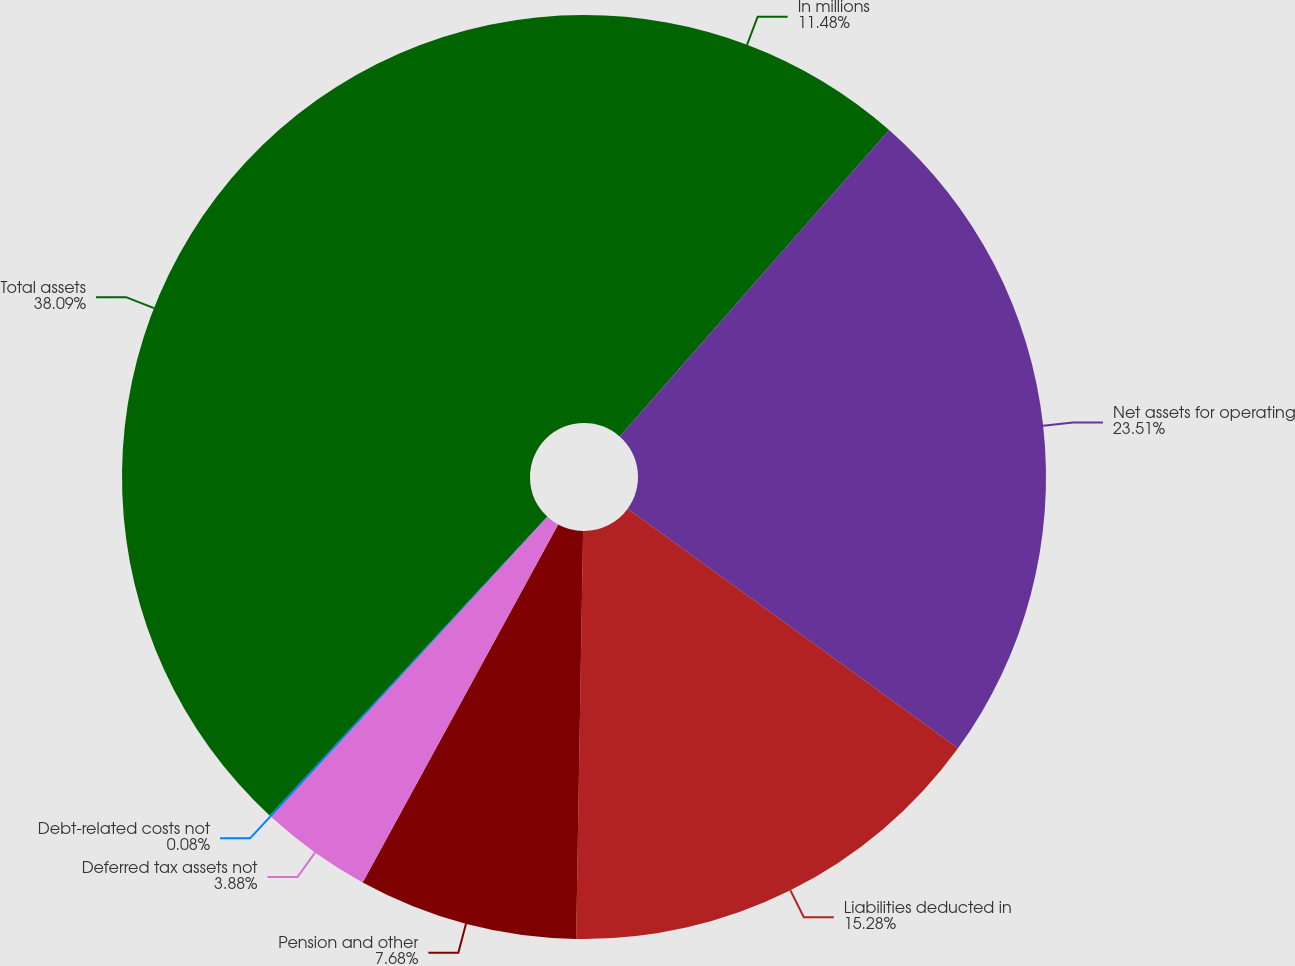<chart> <loc_0><loc_0><loc_500><loc_500><pie_chart><fcel>In millions<fcel>Net assets for operating<fcel>Liabilities deducted in<fcel>Pension and other<fcel>Deferred tax assets not<fcel>Debt-related costs not<fcel>Total assets<nl><fcel>11.48%<fcel>23.5%<fcel>15.28%<fcel>7.68%<fcel>3.88%<fcel>0.08%<fcel>38.08%<nl></chart> 